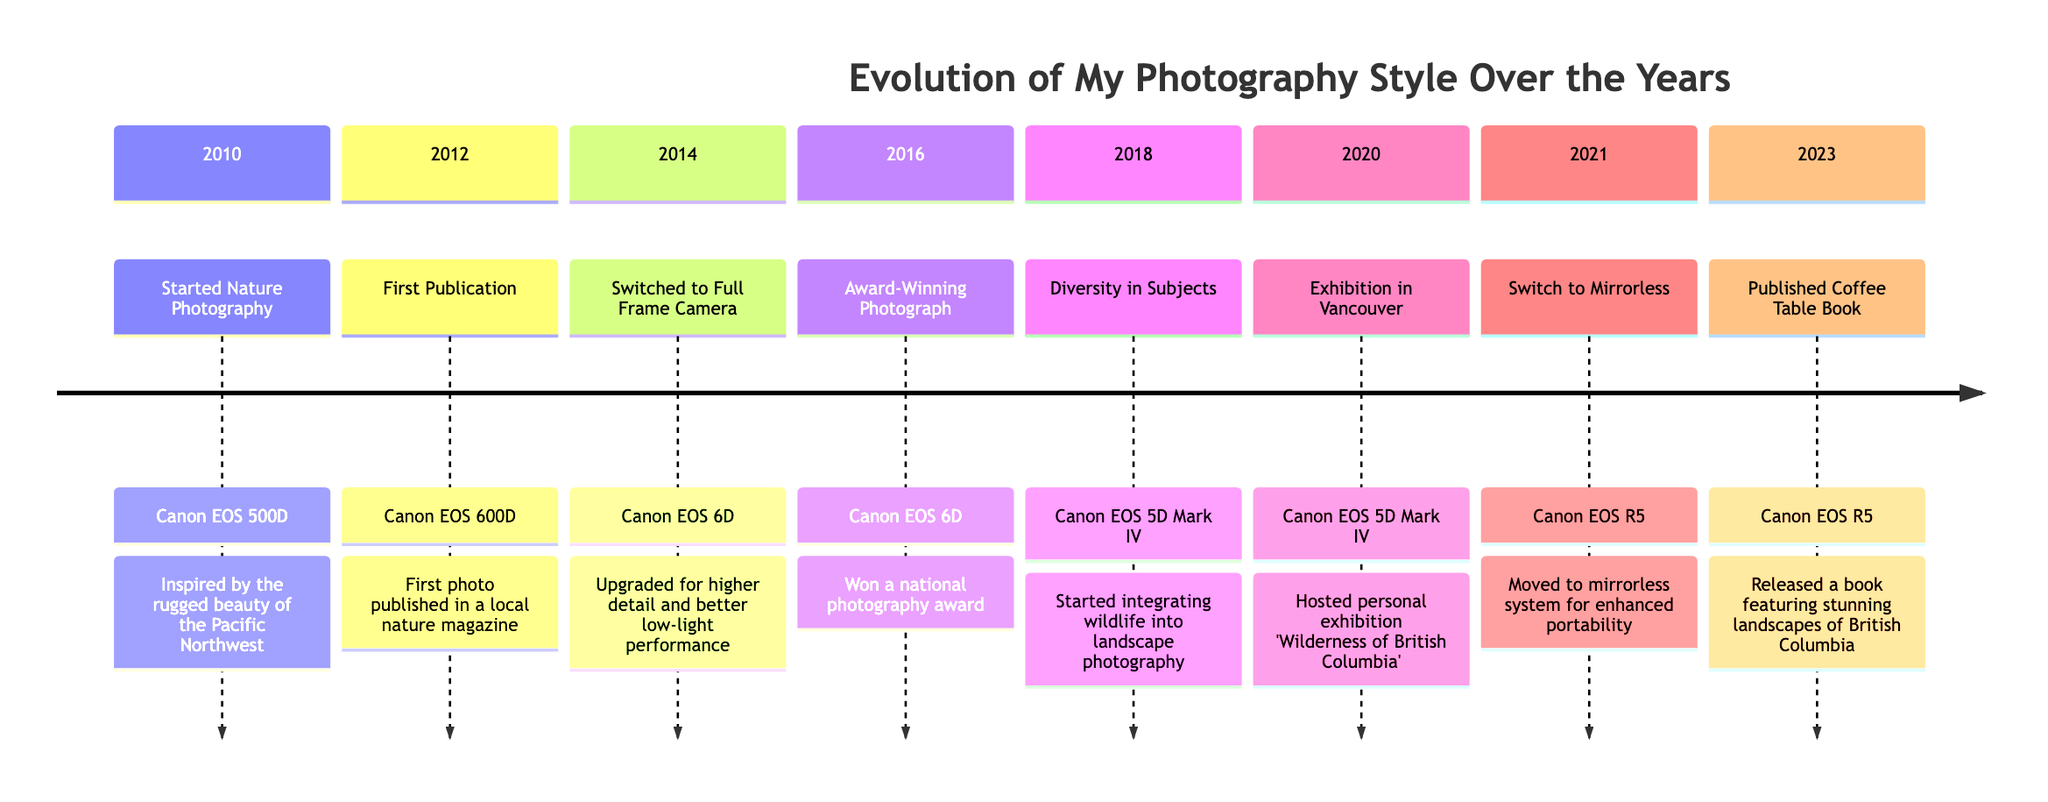What year did you start nature photography? The timeline indicates that nature photography began in 2010, as stated in the first milestone.
Answer: 2010 What camera was used in 2014? According to the timeline, the camera used in 2014 when switching to a full-frame camera was the Canon EOS 6D.
Answer: Canon EOS 6D How many major milestones are recorded in the timeline? By counting each distinct entry in the timeline, we find there are a total of eight major milestones detailed from 2010 to 2023.
Answer: 8 Which milestone corresponds to the year 2021? Referring to the timeline, the milestone for 2021 is "Switch to Mirrorless," representing the transition to new camera technology.
Answer: Switch to Mirrorless What does the 2016 milestone signify? The milestone for 2016 indicates that an award-winning photograph was achieved, which highlights a significant recognition in the photographer's career.
Answer: Award-Winning Photograph In what year was the first publication achieved? From the timeline, the milestone of the first publication occurred in 2012, marking the photographer's entry into published work.
Answer: 2012 What type of camera was primarily used starting in 2021? The timeline reveals that the camera primarily used after 2021 is Canon EOS R5, indicating a shift to mirrorless technology for the photographer.
Answer: Canon EOS R5 What event took place in 2020? The 2020 milestone details an exhibition hosted in Vancouver, showcasing the photographer's works to the public.
Answer: Exhibition in Vancouver How does the equipment evolve from 2010 to 2023? The equipment evolves from DSLR formats (Canon EOS 500D and 600D) to full-frame (Canon EOS 6D, Canon EOS 5D Mark IV) and finally to a mirrorless system (Canon EOS R5), demonstrating an upgrade in technology over the years for improved quality.
Answer: From DSLR to mirrorless 